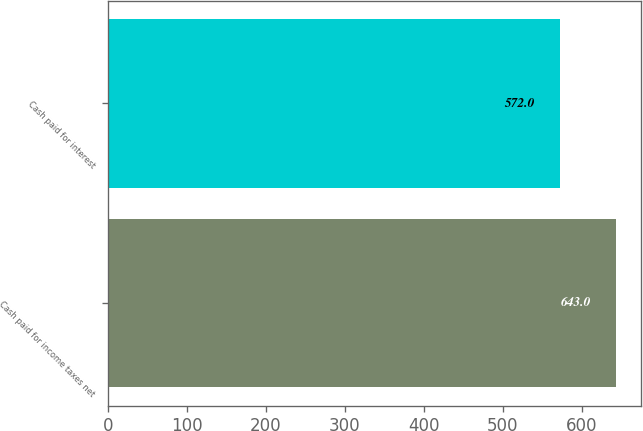<chart> <loc_0><loc_0><loc_500><loc_500><bar_chart><fcel>Cash paid for income taxes net<fcel>Cash paid for interest<nl><fcel>643<fcel>572<nl></chart> 